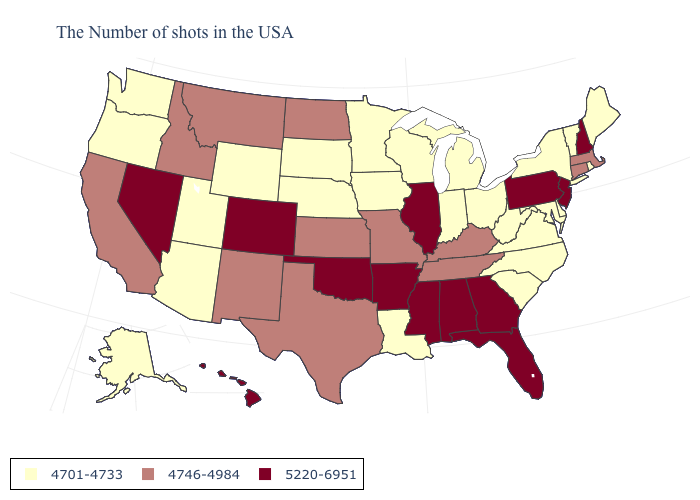Among the states that border Arizona , does Utah have the lowest value?
Be succinct. Yes. What is the value of Maine?
Concise answer only. 4701-4733. Does Nevada have the highest value in the West?
Answer briefly. Yes. What is the value of South Carolina?
Write a very short answer. 4701-4733. Name the states that have a value in the range 4701-4733?
Give a very brief answer. Maine, Rhode Island, Vermont, New York, Delaware, Maryland, Virginia, North Carolina, South Carolina, West Virginia, Ohio, Michigan, Indiana, Wisconsin, Louisiana, Minnesota, Iowa, Nebraska, South Dakota, Wyoming, Utah, Arizona, Washington, Oregon, Alaska. Name the states that have a value in the range 4746-4984?
Write a very short answer. Massachusetts, Connecticut, Kentucky, Tennessee, Missouri, Kansas, Texas, North Dakota, New Mexico, Montana, Idaho, California. Which states have the lowest value in the Northeast?
Keep it brief. Maine, Rhode Island, Vermont, New York. Name the states that have a value in the range 4701-4733?
Give a very brief answer. Maine, Rhode Island, Vermont, New York, Delaware, Maryland, Virginia, North Carolina, South Carolina, West Virginia, Ohio, Michigan, Indiana, Wisconsin, Louisiana, Minnesota, Iowa, Nebraska, South Dakota, Wyoming, Utah, Arizona, Washington, Oregon, Alaska. What is the value of Pennsylvania?
Short answer required. 5220-6951. What is the value of Connecticut?
Quick response, please. 4746-4984. What is the value of California?
Concise answer only. 4746-4984. Does Massachusetts have the highest value in the Northeast?
Write a very short answer. No. What is the highest value in the USA?
Keep it brief. 5220-6951. What is the value of Michigan?
Keep it brief. 4701-4733. What is the highest value in states that border Colorado?
Concise answer only. 5220-6951. 